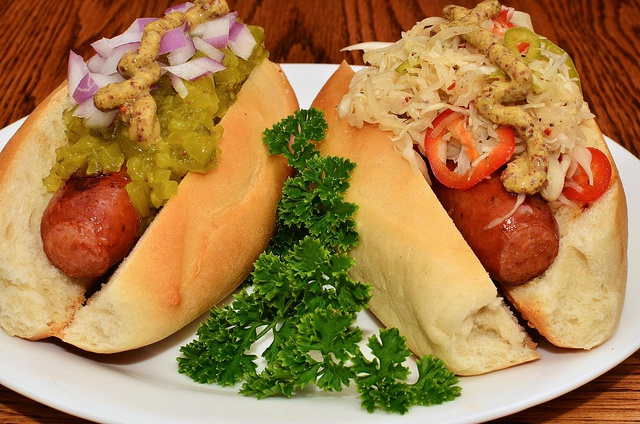Describe the objects in this image and their specific colors. I can see hot dog in maroon, tan, and red tones, hot dog in maroon, orange, olive, and tan tones, carrot in maroon, brown, and red tones, and carrot in maroon, brown, and black tones in this image. 